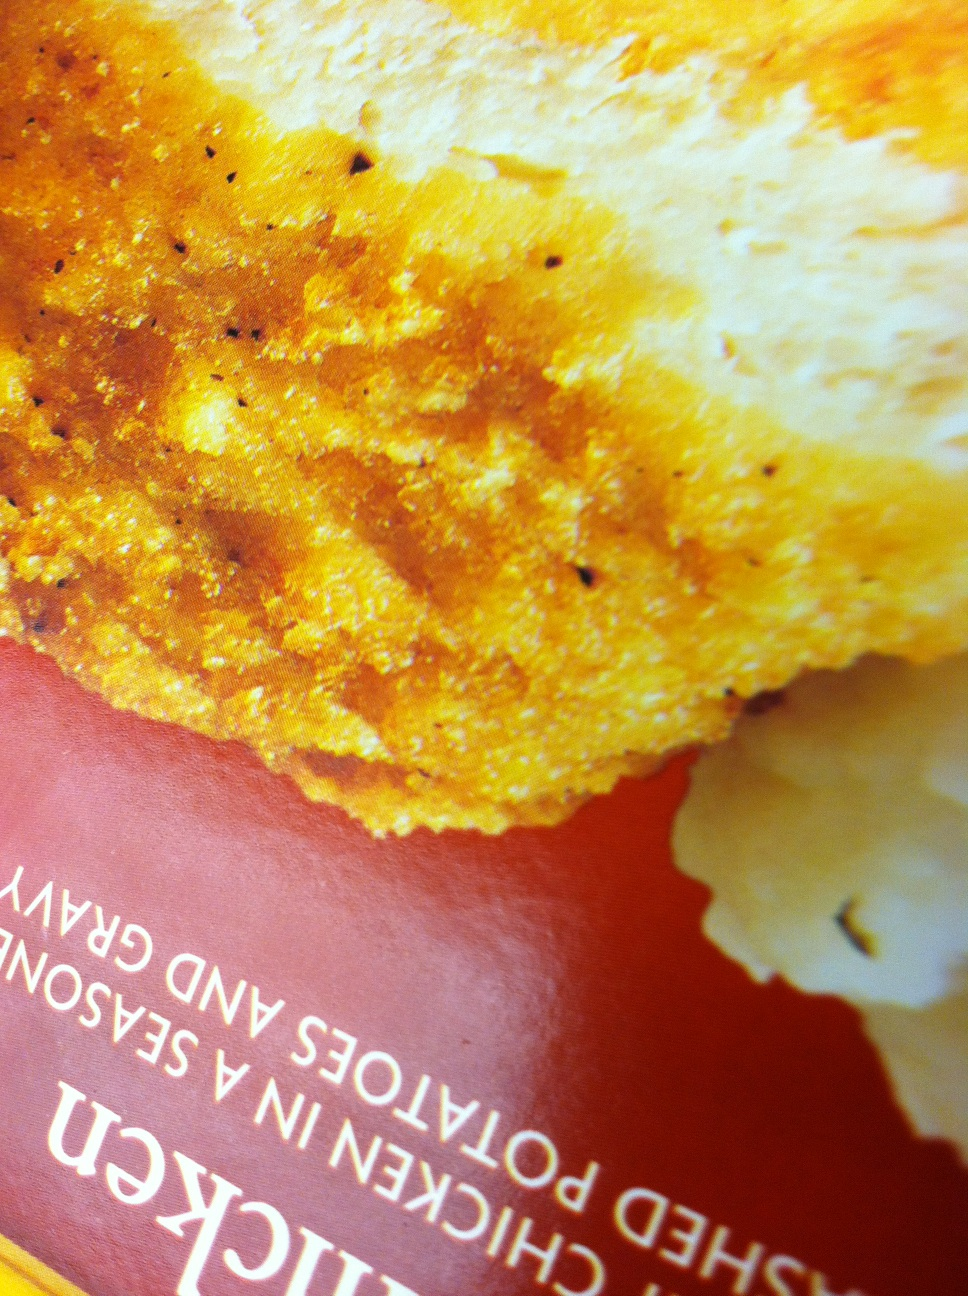What is in this box? The box contains a meal of seasoned chicken alongside mashed potatoes covered with gravy. The chicken appears crispy and well-seasoned, suggesting it might be either baked or fried. 